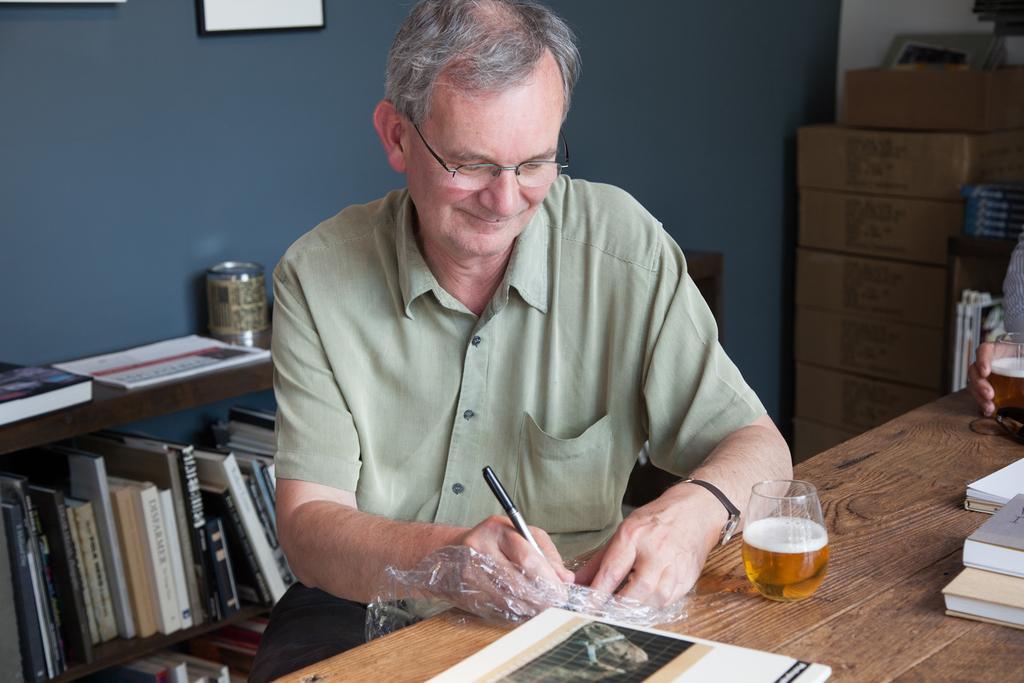Can you describe this image briefly? In this picture we can see a man is sitting in front of a table and writing something, there are some books and two glasses of drinks present on the table, on the left side there is a rack, there are some books on the rack, in the background there is a wall and cardboard boxes, there is frame on the wall, on the right side we can see another person's hand. 